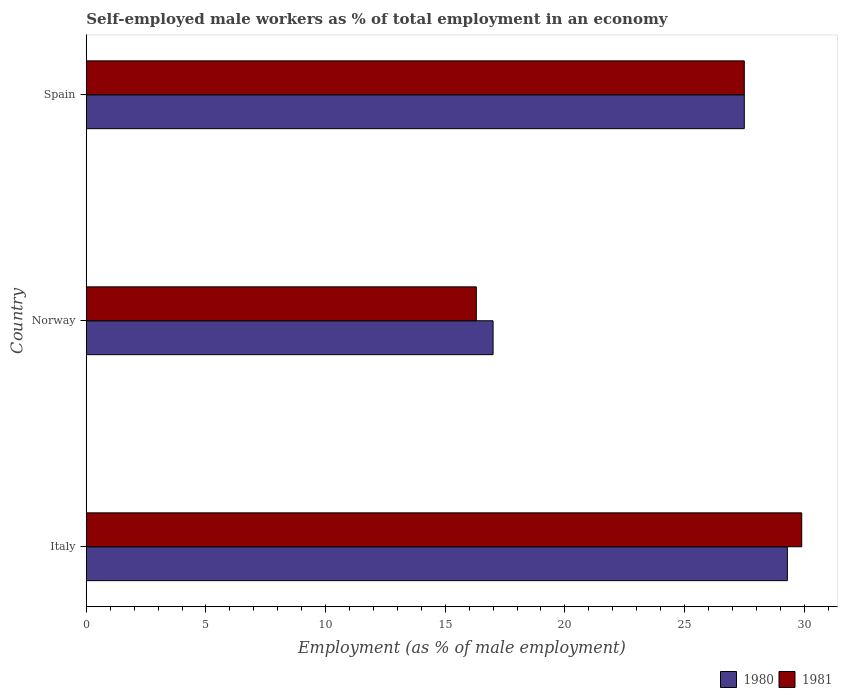How many bars are there on the 2nd tick from the top?
Your answer should be very brief. 2. How many bars are there on the 1st tick from the bottom?
Your answer should be very brief. 2. In how many cases, is the number of bars for a given country not equal to the number of legend labels?
Your response must be concise. 0. Across all countries, what is the maximum percentage of self-employed male workers in 1981?
Give a very brief answer. 29.9. Across all countries, what is the minimum percentage of self-employed male workers in 1981?
Make the answer very short. 16.3. In which country was the percentage of self-employed male workers in 1981 minimum?
Provide a succinct answer. Norway. What is the total percentage of self-employed male workers in 1981 in the graph?
Keep it short and to the point. 73.7. What is the difference between the percentage of self-employed male workers in 1980 in Italy and that in Spain?
Your answer should be very brief. 1.8. What is the average percentage of self-employed male workers in 1981 per country?
Give a very brief answer. 24.57. What is the difference between the percentage of self-employed male workers in 1981 and percentage of self-employed male workers in 1980 in Spain?
Offer a very short reply. 0. In how many countries, is the percentage of self-employed male workers in 1980 greater than 9 %?
Keep it short and to the point. 3. What is the ratio of the percentage of self-employed male workers in 1981 in Italy to that in Norway?
Make the answer very short. 1.83. Is the percentage of self-employed male workers in 1981 in Norway less than that in Spain?
Offer a very short reply. Yes. What is the difference between the highest and the second highest percentage of self-employed male workers in 1981?
Your answer should be very brief. 2.4. What is the difference between the highest and the lowest percentage of self-employed male workers in 1980?
Your answer should be very brief. 12.3. In how many countries, is the percentage of self-employed male workers in 1980 greater than the average percentage of self-employed male workers in 1980 taken over all countries?
Give a very brief answer. 2. What does the 1st bar from the top in Norway represents?
Your answer should be very brief. 1981. How many bars are there?
Your answer should be very brief. 6. Are all the bars in the graph horizontal?
Make the answer very short. Yes. How many countries are there in the graph?
Keep it short and to the point. 3. Does the graph contain grids?
Provide a succinct answer. No. Where does the legend appear in the graph?
Your answer should be compact. Bottom right. How many legend labels are there?
Your answer should be compact. 2. How are the legend labels stacked?
Ensure brevity in your answer.  Horizontal. What is the title of the graph?
Give a very brief answer. Self-employed male workers as % of total employment in an economy. What is the label or title of the X-axis?
Your answer should be very brief. Employment (as % of male employment). What is the Employment (as % of male employment) in 1980 in Italy?
Your answer should be compact. 29.3. What is the Employment (as % of male employment) of 1981 in Italy?
Your answer should be compact. 29.9. What is the Employment (as % of male employment) of 1981 in Norway?
Keep it short and to the point. 16.3. What is the Employment (as % of male employment) of 1980 in Spain?
Ensure brevity in your answer.  27.5. Across all countries, what is the maximum Employment (as % of male employment) in 1980?
Provide a succinct answer. 29.3. Across all countries, what is the maximum Employment (as % of male employment) in 1981?
Offer a very short reply. 29.9. Across all countries, what is the minimum Employment (as % of male employment) in 1980?
Your answer should be very brief. 17. Across all countries, what is the minimum Employment (as % of male employment) in 1981?
Your answer should be compact. 16.3. What is the total Employment (as % of male employment) in 1980 in the graph?
Keep it short and to the point. 73.8. What is the total Employment (as % of male employment) in 1981 in the graph?
Your answer should be very brief. 73.7. What is the difference between the Employment (as % of male employment) in 1980 in Italy and that in Norway?
Your answer should be very brief. 12.3. What is the difference between the Employment (as % of male employment) of 1981 in Italy and that in Norway?
Give a very brief answer. 13.6. What is the difference between the Employment (as % of male employment) of 1980 in Italy and that in Spain?
Give a very brief answer. 1.8. What is the difference between the Employment (as % of male employment) in 1981 in Italy and that in Spain?
Make the answer very short. 2.4. What is the difference between the Employment (as % of male employment) of 1980 in Italy and the Employment (as % of male employment) of 1981 in Spain?
Keep it short and to the point. 1.8. What is the difference between the Employment (as % of male employment) in 1980 in Norway and the Employment (as % of male employment) in 1981 in Spain?
Your answer should be very brief. -10.5. What is the average Employment (as % of male employment) in 1980 per country?
Make the answer very short. 24.6. What is the average Employment (as % of male employment) in 1981 per country?
Make the answer very short. 24.57. What is the ratio of the Employment (as % of male employment) of 1980 in Italy to that in Norway?
Ensure brevity in your answer.  1.72. What is the ratio of the Employment (as % of male employment) of 1981 in Italy to that in Norway?
Your answer should be compact. 1.83. What is the ratio of the Employment (as % of male employment) of 1980 in Italy to that in Spain?
Offer a very short reply. 1.07. What is the ratio of the Employment (as % of male employment) in 1981 in Italy to that in Spain?
Offer a terse response. 1.09. What is the ratio of the Employment (as % of male employment) in 1980 in Norway to that in Spain?
Provide a short and direct response. 0.62. What is the ratio of the Employment (as % of male employment) of 1981 in Norway to that in Spain?
Provide a succinct answer. 0.59. What is the difference between the highest and the second highest Employment (as % of male employment) in 1980?
Provide a succinct answer. 1.8. What is the difference between the highest and the second highest Employment (as % of male employment) of 1981?
Keep it short and to the point. 2.4. What is the difference between the highest and the lowest Employment (as % of male employment) in 1980?
Your response must be concise. 12.3. 